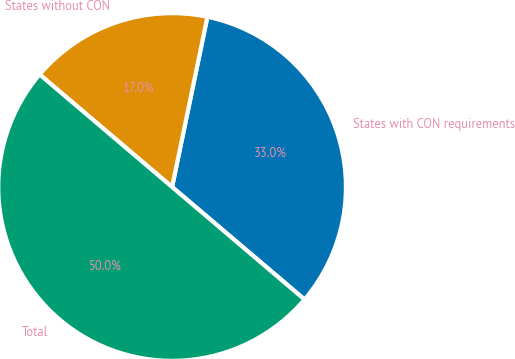Convert chart to OTSL. <chart><loc_0><loc_0><loc_500><loc_500><pie_chart><fcel>States with CON requirements<fcel>States without CON<fcel>Total<nl><fcel>32.95%<fcel>17.05%<fcel>50.0%<nl></chart> 